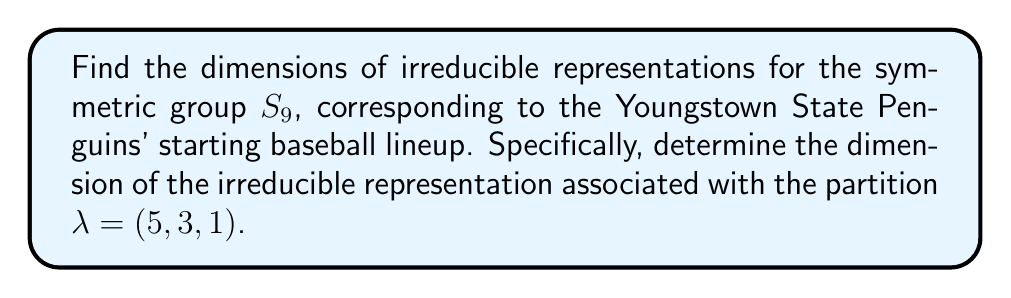Provide a solution to this math problem. To find the dimension of the irreducible representation associated with the partition $\lambda = (5, 3, 1)$ for the symmetric group $S_9$, we can use the hook length formula:

1) First, construct the Young diagram for $\lambda = (5, 3, 1)$:

   [asy]
   unitsize(0.5cm);
   for(int i=0; i<5; ++i) draw((0,0)--(5,0)--(5,-1)--(0,-1)--cycle);
   for(int i=0; i<3; ++i) draw((0,-1)--(3,-1)--(3,-2)--(0,-2)--cycle);
   draw((0,-2)--(1,-2)--(1,-3)--(0,-3)--cycle);
   [/asy]

2) Calculate the hook lengths for each cell:

   [asy]
   unitsize(0.5cm);
   for(int i=0; i<5; ++i) draw((0,0)--(5,0)--(5,-1)--(0,-1)--cycle);
   for(int i=0; i<3; ++i) draw((0,-1)--(3,-1)--(3,-2)--(0,-2)--cycle);
   draw((0,-2)--(1,-2)--(1,-3)--(0,-3)--cycle);
   label("9", (0.5,-0.5));
   label("7", (1.5,-0.5));
   label("6", (2.5,-0.5));
   label("4", (3.5,-0.5));
   label("3", (4.5,-0.5));
   label("5", (0.5,-1.5));
   label("3", (1.5,-1.5));
   label("2", (2.5,-1.5));
   label("1", (0.5,-2.5));
   [/asy]

3) Apply the hook length formula:

   $$\dim V_\lambda = \frac{n!}{\prod_{(i,j)\in \lambda} h(i,j)}$$

   where $n = 9$ (size of $S_9$) and $h(i,j)$ is the hook length of the cell $(i,j)$.

4) Substitute the values:

   $$\dim V_{(5,3,1)} = \frac{9!}{9 \cdot 7 \cdot 6 \cdot 4 \cdot 3 \cdot 5 \cdot 3 \cdot 2 \cdot 1}$$

5) Calculate:
   
   $$\dim V_{(5,3,1)} = \frac{362880}{45360} = 8$$

Thus, the dimension of the irreducible representation associated with $\lambda = (5, 3, 1)$ is 8.
Answer: 8 